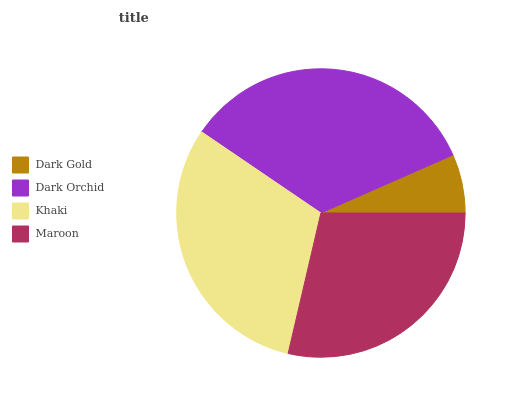Is Dark Gold the minimum?
Answer yes or no. Yes. Is Dark Orchid the maximum?
Answer yes or no. Yes. Is Khaki the minimum?
Answer yes or no. No. Is Khaki the maximum?
Answer yes or no. No. Is Dark Orchid greater than Khaki?
Answer yes or no. Yes. Is Khaki less than Dark Orchid?
Answer yes or no. Yes. Is Khaki greater than Dark Orchid?
Answer yes or no. No. Is Dark Orchid less than Khaki?
Answer yes or no. No. Is Khaki the high median?
Answer yes or no. Yes. Is Maroon the low median?
Answer yes or no. Yes. Is Maroon the high median?
Answer yes or no. No. Is Dark Gold the low median?
Answer yes or no. No. 